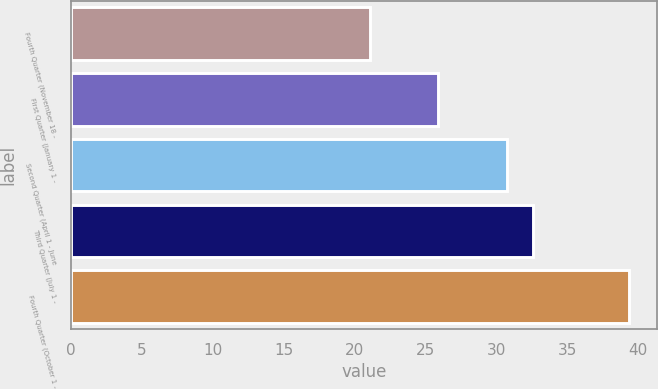Convert chart. <chart><loc_0><loc_0><loc_500><loc_500><bar_chart><fcel>Fourth Quarter (November 18 -<fcel>First Quarter (January 1 -<fcel>Second Quarter (April 1 - June<fcel>Third Quarter (July 1 -<fcel>Fourth Quarter (October 1 -<nl><fcel>21.08<fcel>25.85<fcel>30.75<fcel>32.58<fcel>39.33<nl></chart> 